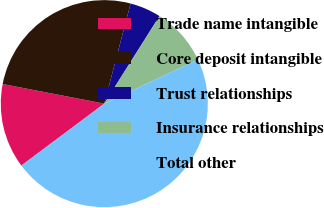<chart> <loc_0><loc_0><loc_500><loc_500><pie_chart><fcel>Trade name intangible<fcel>Core deposit intangible<fcel>Trust relationships<fcel>Insurance relationships<fcel>Total other<nl><fcel>13.24%<fcel>26.06%<fcel>4.86%<fcel>9.05%<fcel>46.79%<nl></chart> 